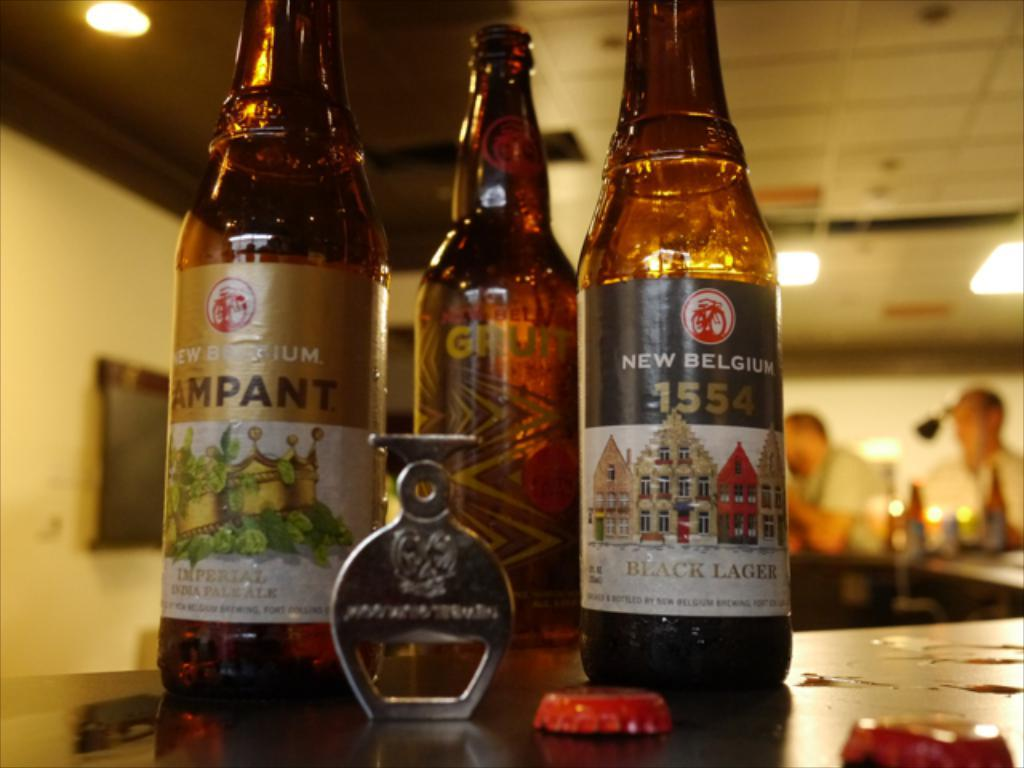<image>
Present a compact description of the photo's key features. three bottles standing next to each other with one of them labeled 'new belgium' 